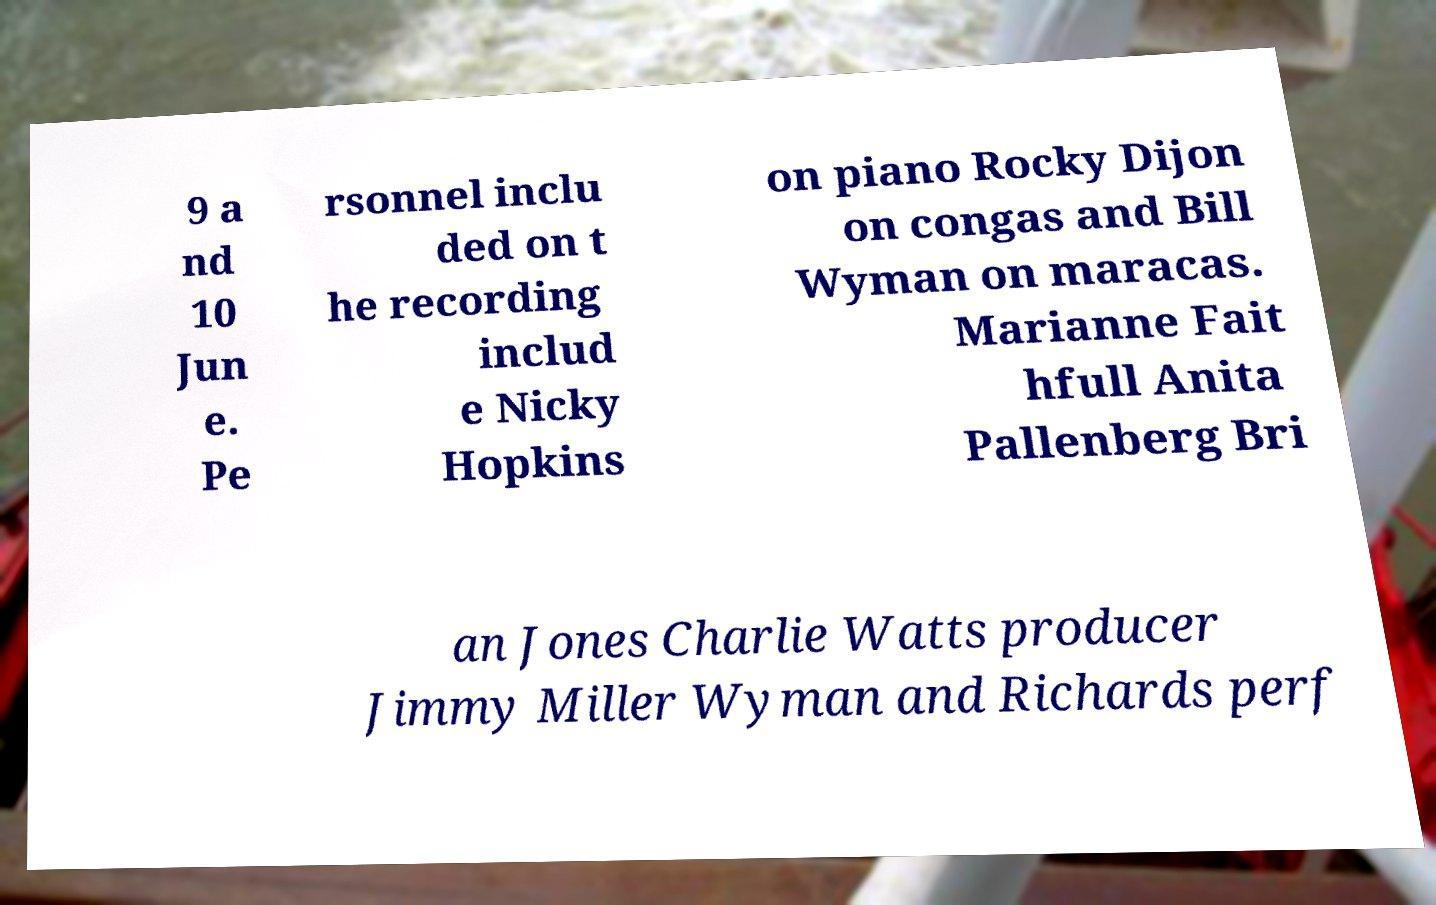Could you assist in decoding the text presented in this image and type it out clearly? 9 a nd 10 Jun e. Pe rsonnel inclu ded on t he recording includ e Nicky Hopkins on piano Rocky Dijon on congas and Bill Wyman on maracas. Marianne Fait hfull Anita Pallenberg Bri an Jones Charlie Watts producer Jimmy Miller Wyman and Richards perf 